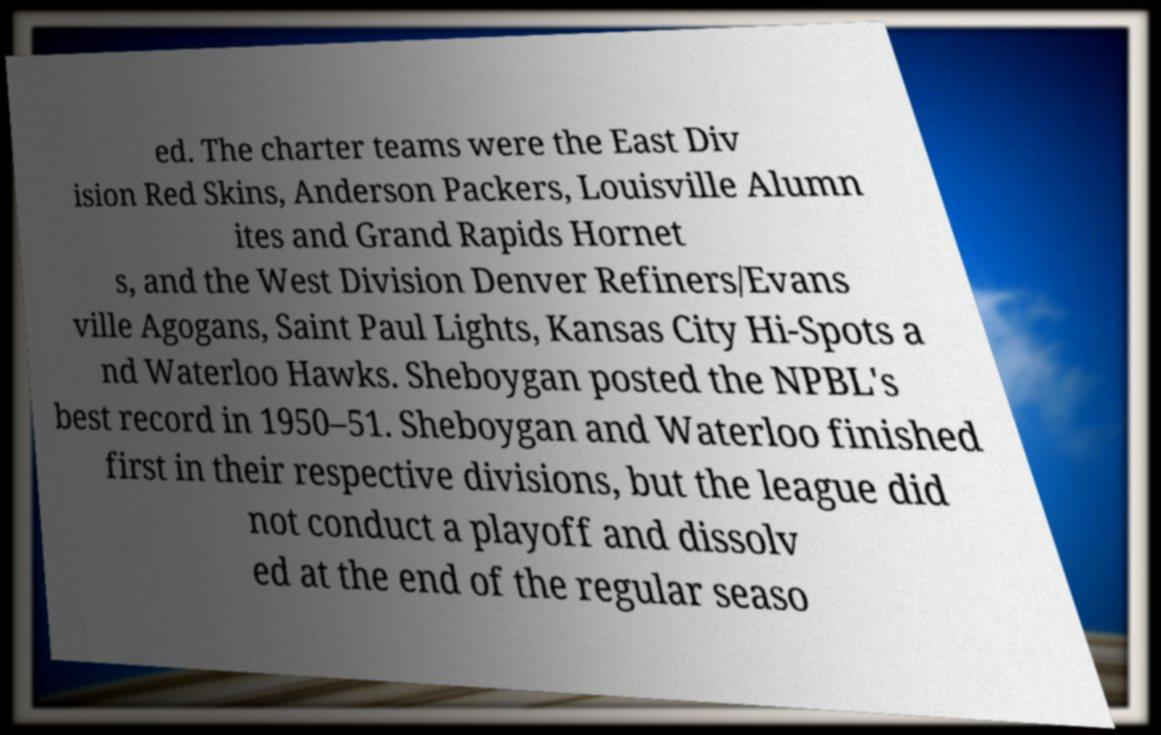Can you read and provide the text displayed in the image?This photo seems to have some interesting text. Can you extract and type it out for me? ed. The charter teams were the East Div ision Red Skins, Anderson Packers, Louisville Alumn ites and Grand Rapids Hornet s, and the West Division Denver Refiners/Evans ville Agogans, Saint Paul Lights, Kansas City Hi-Spots a nd Waterloo Hawks. Sheboygan posted the NPBL's best record in 1950–51. Sheboygan and Waterloo finished first in their respective divisions, but the league did not conduct a playoff and dissolv ed at the end of the regular seaso 